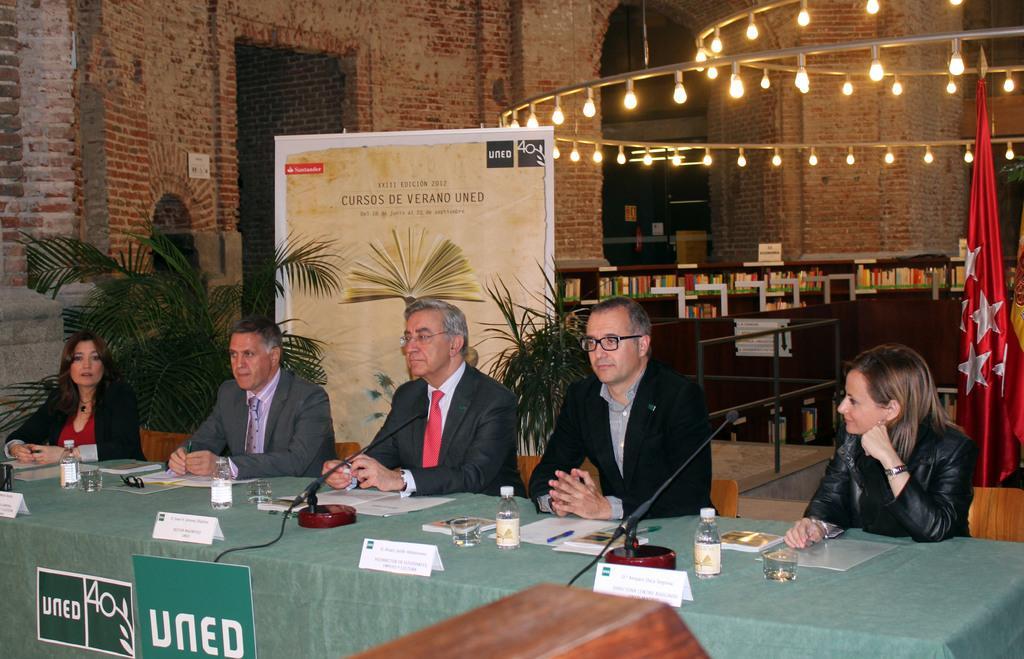In one or two sentences, can you explain what this image depicts? In this picture I can see few people seated on the chairs and I can see papers, microphones, water glasses and water bottles on the table and I can see an advertisement board with some text and I can see couple of boards with some text and I can see lights and few books in the bookshelf and I can see couple of flags on the right side of the picture and I can see brick wall on the left side and couple of plants in the pots. 